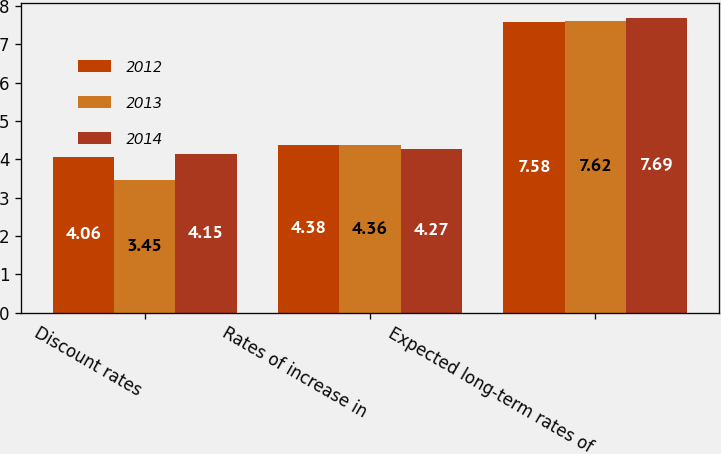Convert chart. <chart><loc_0><loc_0><loc_500><loc_500><stacked_bar_chart><ecel><fcel>Discount rates<fcel>Rates of increase in<fcel>Expected long-term rates of<nl><fcel>2012<fcel>4.06<fcel>4.38<fcel>7.58<nl><fcel>2013<fcel>3.45<fcel>4.36<fcel>7.62<nl><fcel>2014<fcel>4.15<fcel>4.27<fcel>7.69<nl></chart> 